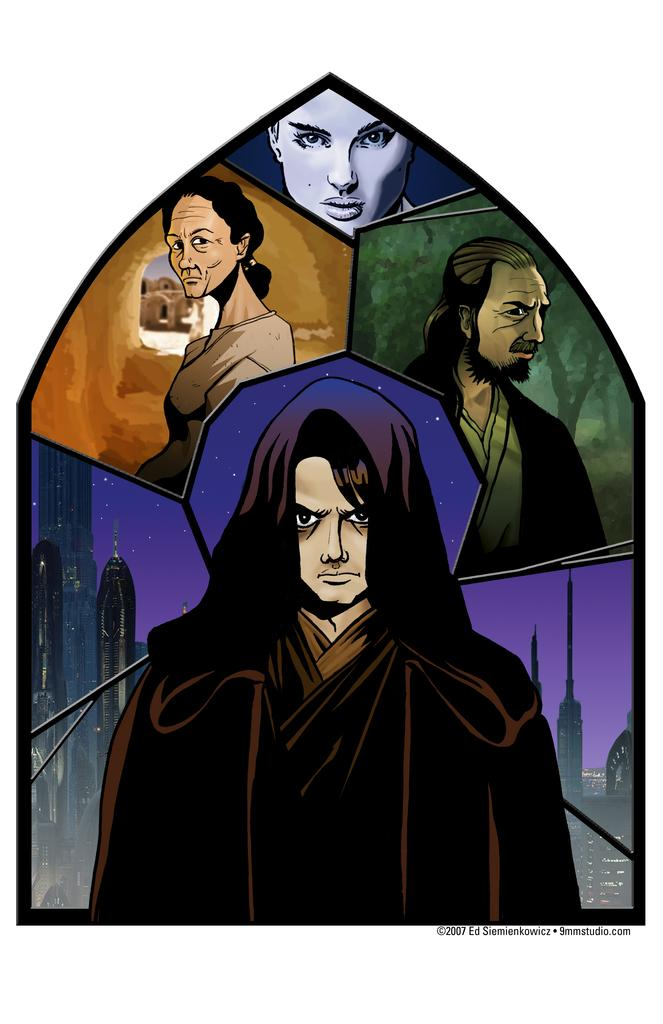What is featured in the image? There is a poster in the image. What can be seen on the poster? The poster contains pictures of four people and buildings. What are the people on the poster wearing? The people on the poster are wearing clothes. Is there a foggy atmosphere surrounding the people on the poster? There is no mention of fog in the image or the poster, so it cannot be determined from the information provided. 